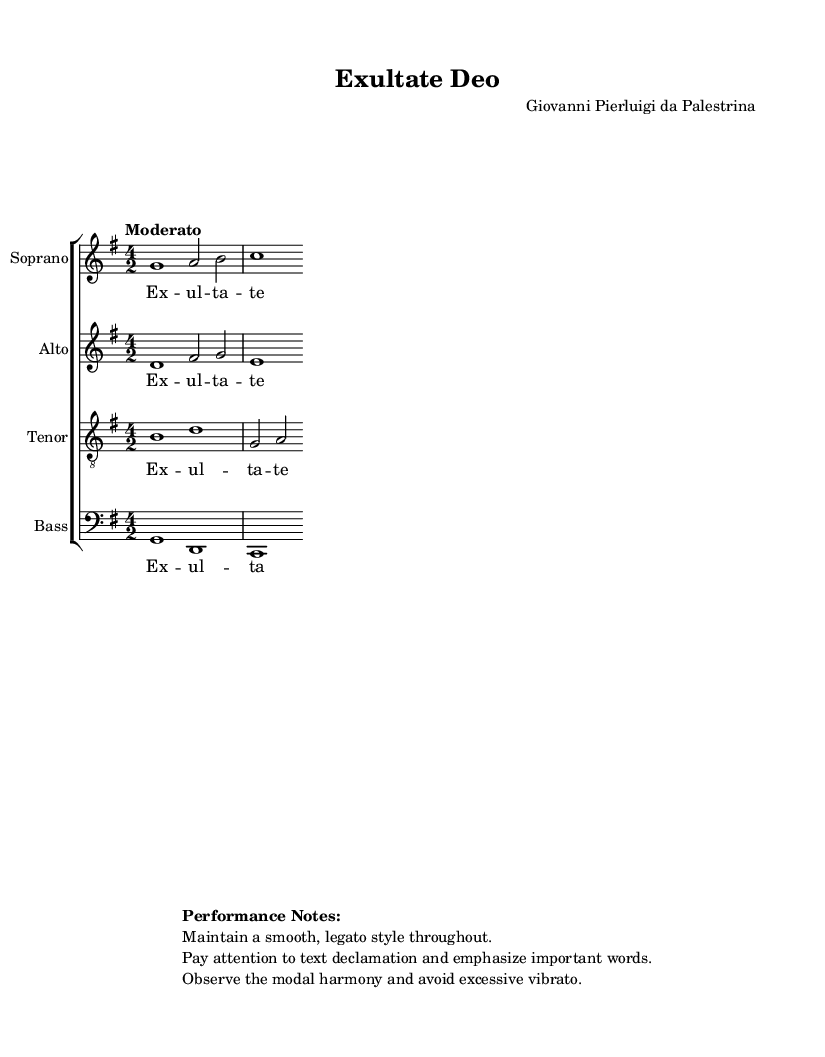What is the key signature of this music? The key signature is found at the beginning of the staff, indicating G major, which has one sharp (F#).
Answer: G major What is the time signature of this piece? The time signature appears right after the key signature, showing a 4/2 pulse, which indicates four half-note beats in a measure.
Answer: 4/2 What is the tempo indicated for this piece? The tempo marking is written above the staff. It states "Moderato," which signifies a moderate pace for the performance.
Answer: Moderato How many vocal parts are present in this choral work? By counting the individual staves in the score, one can see there are four distinct parts: Soprano, Alto, Tenor, and Bass.
Answer: Four What type of harmony is primarily used in this composition? Key indicators such as chords and voicing suggest that modal harmony is employed throughout this piece, typical for Renaissance music.
Answer: Modal harmony What is the title of this piece? The title appears at the header of the score, indicating the work's identity. "Exultate Deo" is notably recognized as a sacred choral work.
Answer: Exultate Deo What should be emphasized during the performance according to the performance notes? The performance notes highlight that important words in the text should be emphasized during the singing, guiding expression and clarity in the interpretation.
Answer: Important words 